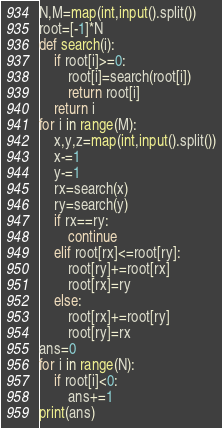<code> <loc_0><loc_0><loc_500><loc_500><_Python_>N,M=map(int,input().split())
root=[-1]*N
def search(i):
    if root[i]>=0:
        root[i]=search(root[i])
        return root[i]
    return i
for i in range(M):
    x,y,z=map(int,input().split())
    x-=1
    y-=1
    rx=search(x)
    ry=search(y)
    if rx==ry:
        continue
    elif root[rx]<=root[ry]:
        root[ry]+=root[rx]
        root[rx]=ry
    else:
        root[rx]+=root[ry]
        root[ry]=rx
ans=0
for i in range(N):
    if root[i]<0:
        ans+=1
print(ans)
</code> 